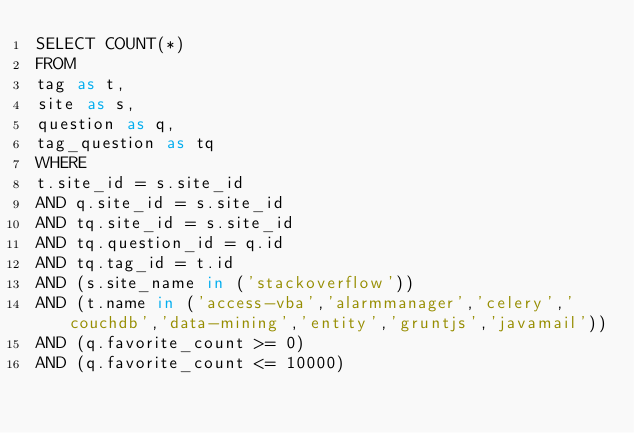Convert code to text. <code><loc_0><loc_0><loc_500><loc_500><_SQL_>SELECT COUNT(*)
FROM
tag as t,
site as s,
question as q,
tag_question as tq
WHERE
t.site_id = s.site_id
AND q.site_id = s.site_id
AND tq.site_id = s.site_id
AND tq.question_id = q.id
AND tq.tag_id = t.id
AND (s.site_name in ('stackoverflow'))
AND (t.name in ('access-vba','alarmmanager','celery','couchdb','data-mining','entity','gruntjs','javamail'))
AND (q.favorite_count >= 0)
AND (q.favorite_count <= 10000)
</code> 